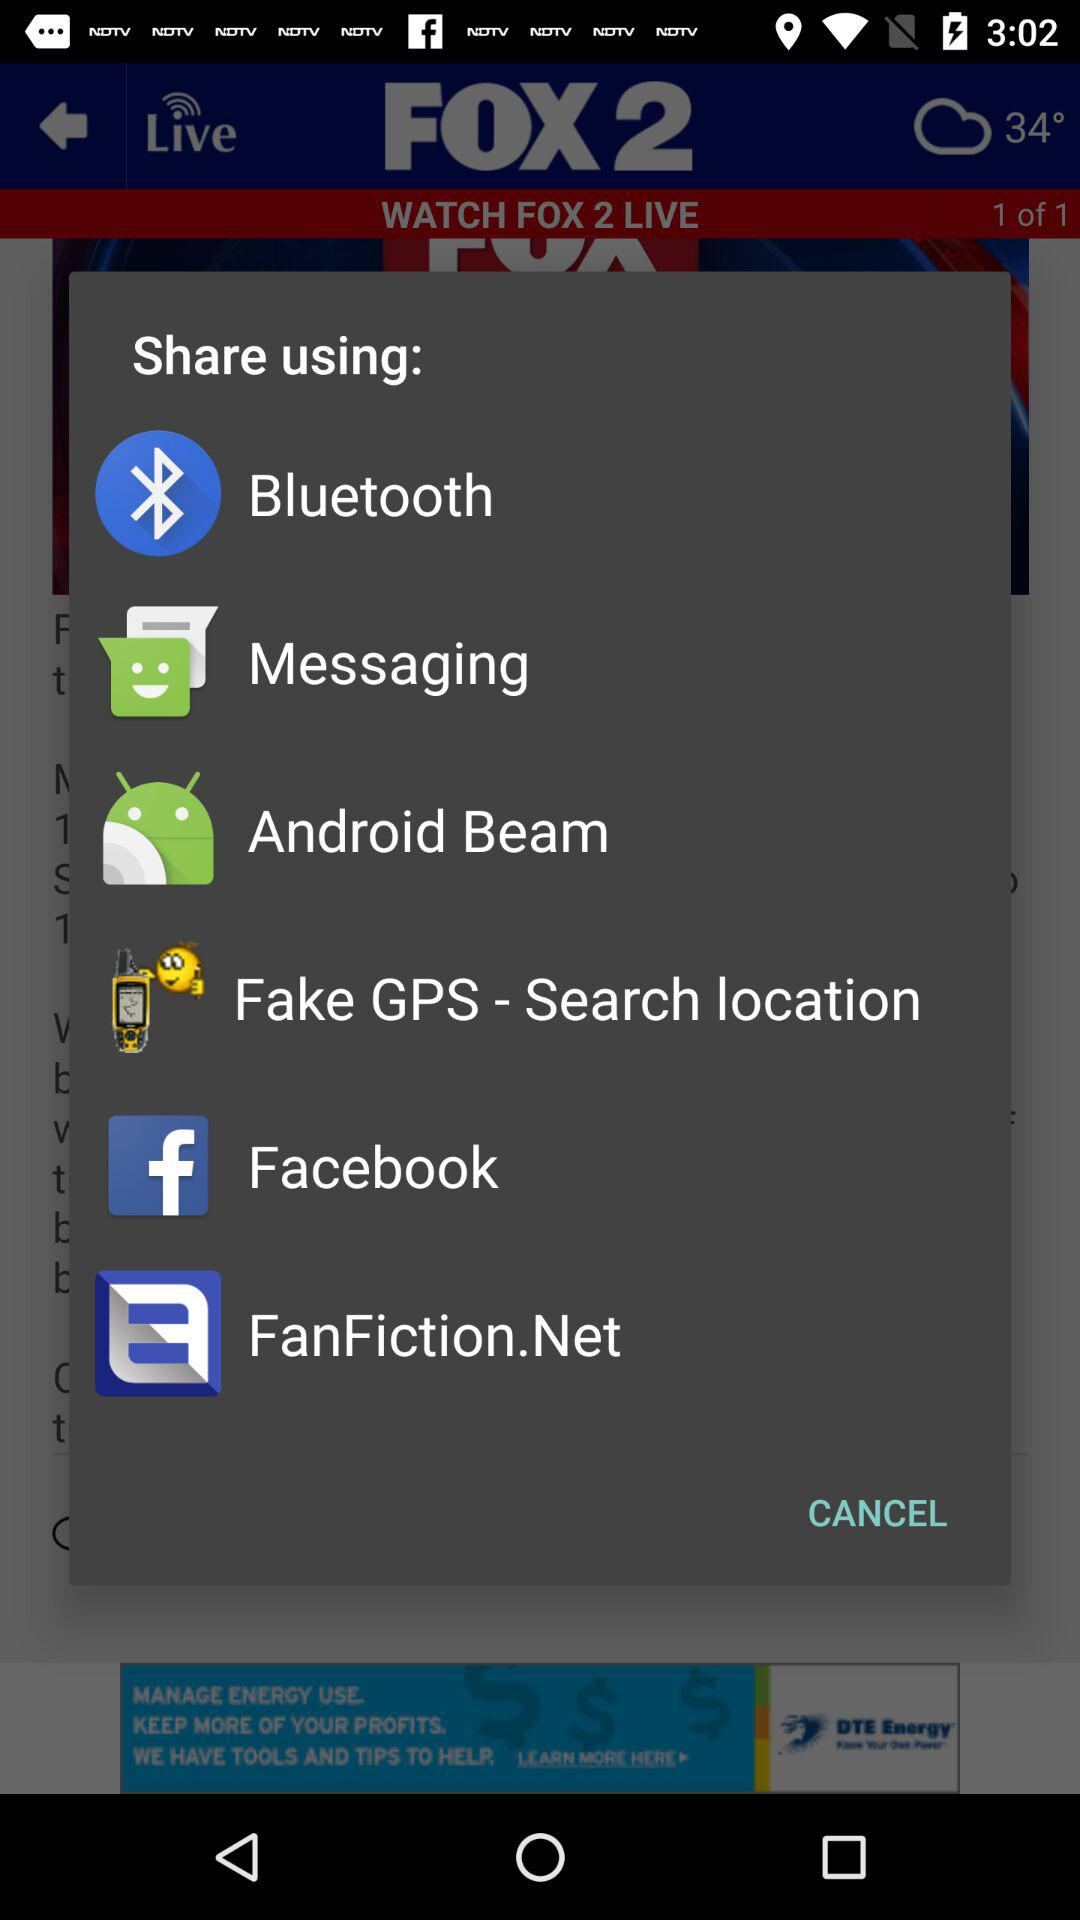What are the sharing options? The sharing options are : "Bluetooth", "Messaging", "Android Beam", "Fake GPS - Search location", "Facebook", and "FanFiction.Net". 